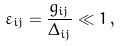Convert formula to latex. <formula><loc_0><loc_0><loc_500><loc_500>\varepsilon _ { i j } = \frac { g _ { i j } } { \Delta _ { i j } } \ll 1 \, ,</formula> 